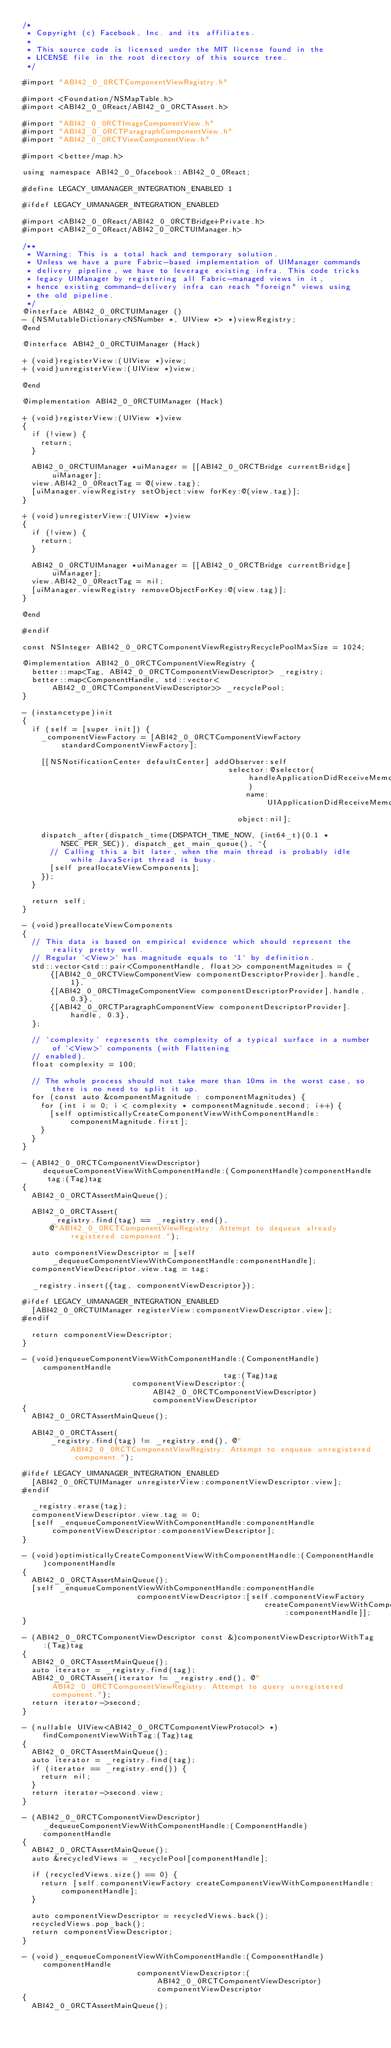<code> <loc_0><loc_0><loc_500><loc_500><_ObjectiveC_>/*
 * Copyright (c) Facebook, Inc. and its affiliates.
 *
 * This source code is licensed under the MIT license found in the
 * LICENSE file in the root directory of this source tree.
 */

#import "ABI42_0_0RCTComponentViewRegistry.h"

#import <Foundation/NSMapTable.h>
#import <ABI42_0_0React/ABI42_0_0RCTAssert.h>

#import "ABI42_0_0RCTImageComponentView.h"
#import "ABI42_0_0RCTParagraphComponentView.h"
#import "ABI42_0_0RCTViewComponentView.h"

#import <better/map.h>

using namespace ABI42_0_0facebook::ABI42_0_0React;

#define LEGACY_UIMANAGER_INTEGRATION_ENABLED 1

#ifdef LEGACY_UIMANAGER_INTEGRATION_ENABLED

#import <ABI42_0_0React/ABI42_0_0RCTBridge+Private.h>
#import <ABI42_0_0React/ABI42_0_0RCTUIManager.h>

/**
 * Warning: This is a total hack and temporary solution.
 * Unless we have a pure Fabric-based implementation of UIManager commands
 * delivery pipeline, we have to leverage existing infra. This code tricks
 * legacy UIManager by registering all Fabric-managed views in it,
 * hence existing command-delivery infra can reach "foreign" views using
 * the old pipeline.
 */
@interface ABI42_0_0RCTUIManager ()
- (NSMutableDictionary<NSNumber *, UIView *> *)viewRegistry;
@end

@interface ABI42_0_0RCTUIManager (Hack)

+ (void)registerView:(UIView *)view;
+ (void)unregisterView:(UIView *)view;

@end

@implementation ABI42_0_0RCTUIManager (Hack)

+ (void)registerView:(UIView *)view
{
  if (!view) {
    return;
  }

  ABI42_0_0RCTUIManager *uiManager = [[ABI42_0_0RCTBridge currentBridge] uiManager];
  view.ABI42_0_0ReactTag = @(view.tag);
  [uiManager.viewRegistry setObject:view forKey:@(view.tag)];
}

+ (void)unregisterView:(UIView *)view
{
  if (!view) {
    return;
  }

  ABI42_0_0RCTUIManager *uiManager = [[ABI42_0_0RCTBridge currentBridge] uiManager];
  view.ABI42_0_0ReactTag = nil;
  [uiManager.viewRegistry removeObjectForKey:@(view.tag)];
}

@end

#endif

const NSInteger ABI42_0_0RCTComponentViewRegistryRecyclePoolMaxSize = 1024;

@implementation ABI42_0_0RCTComponentViewRegistry {
  better::map<Tag, ABI42_0_0RCTComponentViewDescriptor> _registry;
  better::map<ComponentHandle, std::vector<ABI42_0_0RCTComponentViewDescriptor>> _recyclePool;
}

- (instancetype)init
{
  if (self = [super init]) {
    _componentViewFactory = [ABI42_0_0RCTComponentViewFactory standardComponentViewFactory];

    [[NSNotificationCenter defaultCenter] addObserver:self
                                             selector:@selector(handleApplicationDidReceiveMemoryWarningNotification)
                                                 name:UIApplicationDidReceiveMemoryWarningNotification
                                               object:nil];

    dispatch_after(dispatch_time(DISPATCH_TIME_NOW, (int64_t)(0.1 * NSEC_PER_SEC)), dispatch_get_main_queue(), ^{
      // Calling this a bit later, when the main thread is probably idle while JavaScript thread is busy.
      [self preallocateViewComponents];
    });
  }

  return self;
}

- (void)preallocateViewComponents
{
  // This data is based on empirical evidence which should represent the reality pretty well.
  // Regular `<View>` has magnitude equals to `1` by definition.
  std::vector<std::pair<ComponentHandle, float>> componentMagnitudes = {
      {[ABI42_0_0RCTViewComponentView componentDescriptorProvider].handle, 1},
      {[ABI42_0_0RCTImageComponentView componentDescriptorProvider].handle, 0.3},
      {[ABI42_0_0RCTParagraphComponentView componentDescriptorProvider].handle, 0.3},
  };

  // `complexity` represents the complexity of a typical surface in a number of `<View>` components (with Flattening
  // enabled).
  float complexity = 100;

  // The whole process should not take more than 10ms in the worst case, so there is no need to split it up.
  for (const auto &componentMagnitude : componentMagnitudes) {
    for (int i = 0; i < complexity * componentMagnitude.second; i++) {
      [self optimisticallyCreateComponentViewWithComponentHandle:componentMagnitude.first];
    }
  }
}

- (ABI42_0_0RCTComponentViewDescriptor)dequeueComponentViewWithComponentHandle:(ComponentHandle)componentHandle tag:(Tag)tag
{
  ABI42_0_0RCTAssertMainQueue();

  ABI42_0_0RCTAssert(
      _registry.find(tag) == _registry.end(),
      @"ABI42_0_0RCTComponentViewRegistry: Attempt to dequeue already registered component.");

  auto componentViewDescriptor = [self _dequeueComponentViewWithComponentHandle:componentHandle];
  componentViewDescriptor.view.tag = tag;

  _registry.insert({tag, componentViewDescriptor});

#ifdef LEGACY_UIMANAGER_INTEGRATION_ENABLED
  [ABI42_0_0RCTUIManager registerView:componentViewDescriptor.view];
#endif

  return componentViewDescriptor;
}

- (void)enqueueComponentViewWithComponentHandle:(ComponentHandle)componentHandle
                                            tag:(Tag)tag
                        componentViewDescriptor:(ABI42_0_0RCTComponentViewDescriptor)componentViewDescriptor
{
  ABI42_0_0RCTAssertMainQueue();

  ABI42_0_0RCTAssert(
      _registry.find(tag) != _registry.end(), @"ABI42_0_0RCTComponentViewRegistry: Attempt to enqueue unregistered component.");

#ifdef LEGACY_UIMANAGER_INTEGRATION_ENABLED
  [ABI42_0_0RCTUIManager unregisterView:componentViewDescriptor.view];
#endif

  _registry.erase(tag);
  componentViewDescriptor.view.tag = 0;
  [self _enqueueComponentViewWithComponentHandle:componentHandle componentViewDescriptor:componentViewDescriptor];
}

- (void)optimisticallyCreateComponentViewWithComponentHandle:(ComponentHandle)componentHandle
{
  ABI42_0_0RCTAssertMainQueue();
  [self _enqueueComponentViewWithComponentHandle:componentHandle
                         componentViewDescriptor:[self.componentViewFactory
                                                     createComponentViewWithComponentHandle:componentHandle]];
}

- (ABI42_0_0RCTComponentViewDescriptor const &)componentViewDescriptorWithTag:(Tag)tag
{
  ABI42_0_0RCTAssertMainQueue();
  auto iterator = _registry.find(tag);
  ABI42_0_0RCTAssert(iterator != _registry.end(), @"ABI42_0_0RCTComponentViewRegistry: Attempt to query unregistered component.");
  return iterator->second;
}

- (nullable UIView<ABI42_0_0RCTComponentViewProtocol> *)findComponentViewWithTag:(Tag)tag
{
  ABI42_0_0RCTAssertMainQueue();
  auto iterator = _registry.find(tag);
  if (iterator == _registry.end()) {
    return nil;
  }
  return iterator->second.view;
}

- (ABI42_0_0RCTComponentViewDescriptor)_dequeueComponentViewWithComponentHandle:(ComponentHandle)componentHandle
{
  ABI42_0_0RCTAssertMainQueue();
  auto &recycledViews = _recyclePool[componentHandle];

  if (recycledViews.size() == 0) {
    return [self.componentViewFactory createComponentViewWithComponentHandle:componentHandle];
  }

  auto componentViewDescriptor = recycledViews.back();
  recycledViews.pop_back();
  return componentViewDescriptor;
}

- (void)_enqueueComponentViewWithComponentHandle:(ComponentHandle)componentHandle
                         componentViewDescriptor:(ABI42_0_0RCTComponentViewDescriptor)componentViewDescriptor
{
  ABI42_0_0RCTAssertMainQueue();</code> 